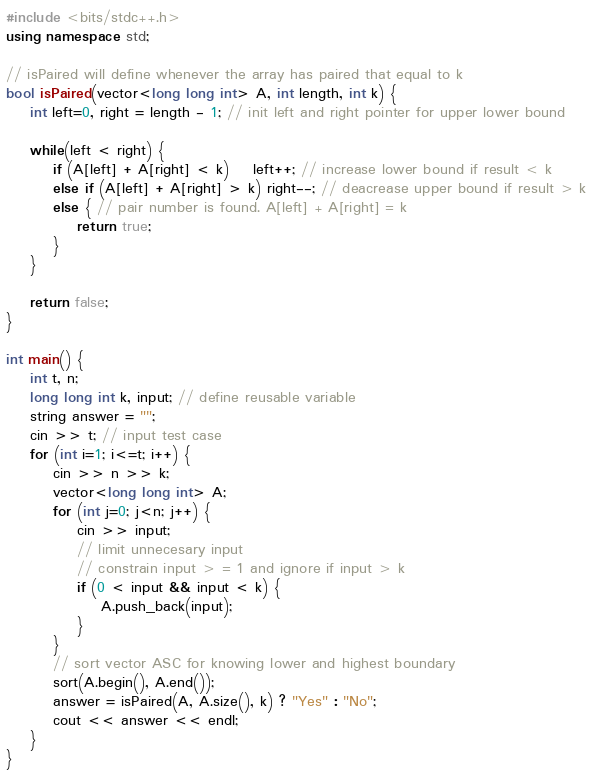Convert code to text. <code><loc_0><loc_0><loc_500><loc_500><_C++_>#include <bits/stdc++.h>
using namespace std;

// isPaired will define whenever the array has paired that equal to k
bool isPaired(vector<long long int> A, int length, int k) {
	int left=0, right = length - 1; // init left and right pointer for upper lower bound

	while(left < right) {
	    if (A[left] + A[right] < k)	left++; // increase lower bound if result < k
		else if (A[left] + A[right] > k) right--; // deacrease upper bound if result > k
	    else { // pair number is found. A[left] + A[right] = k
	        return true;
	    }
	}

    return false;
}

int main() {
	int t, n;
	long long int k, input; // define reusable variable
	string answer = "";
	cin >> t; // input test case
	for (int i=1; i<=t; i++) {
	    cin >> n >> k;
	    vector<long long int> A;
	    for (int j=0; j<n; j++) {
	        cin >> input;
			// limit unnecesary input
			// constrain input > = 1 and ignore if input > k
	        if (0 < input && input < k) {
	            A.push_back(input);
	        }
	    }
		// sort vector ASC for knowing lower and highest boundary
	    sort(A.begin(), A.end());
	    answer = isPaired(A, A.size(), k) ? "Yes" : "No";
	    cout << answer << endl;
	}
}
</code> 